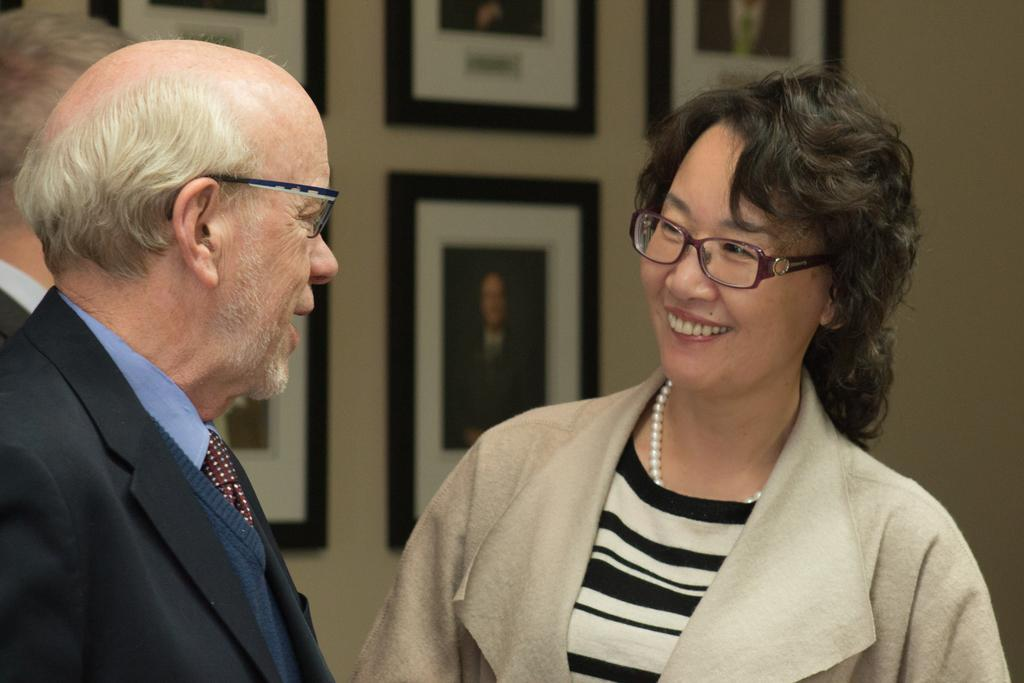What is happening in the image? There are people standing in the image. What can be seen on the wall in the image? There are photo frames on the wall in the image. Can you describe the appearance of some people in the image? Some people in the image are wearing spectacles. What is the chance of an ant being present in the image? There is no mention of an ant in the image, so it is impossible to determine the chance of its presence. 